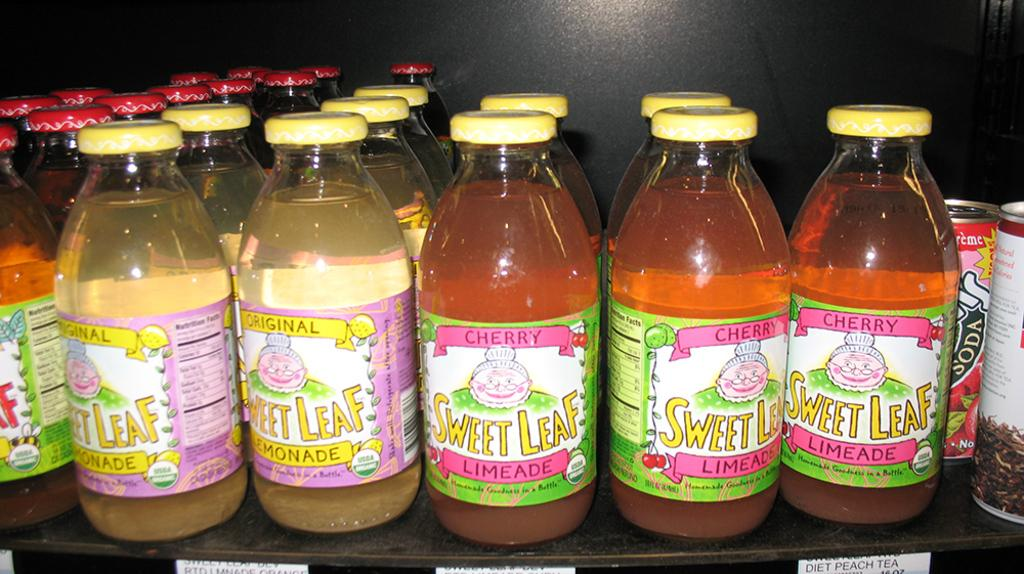<image>
Provide a brief description of the given image. Many bottles of Cherry Sweet Leaf on top of a shelf. 